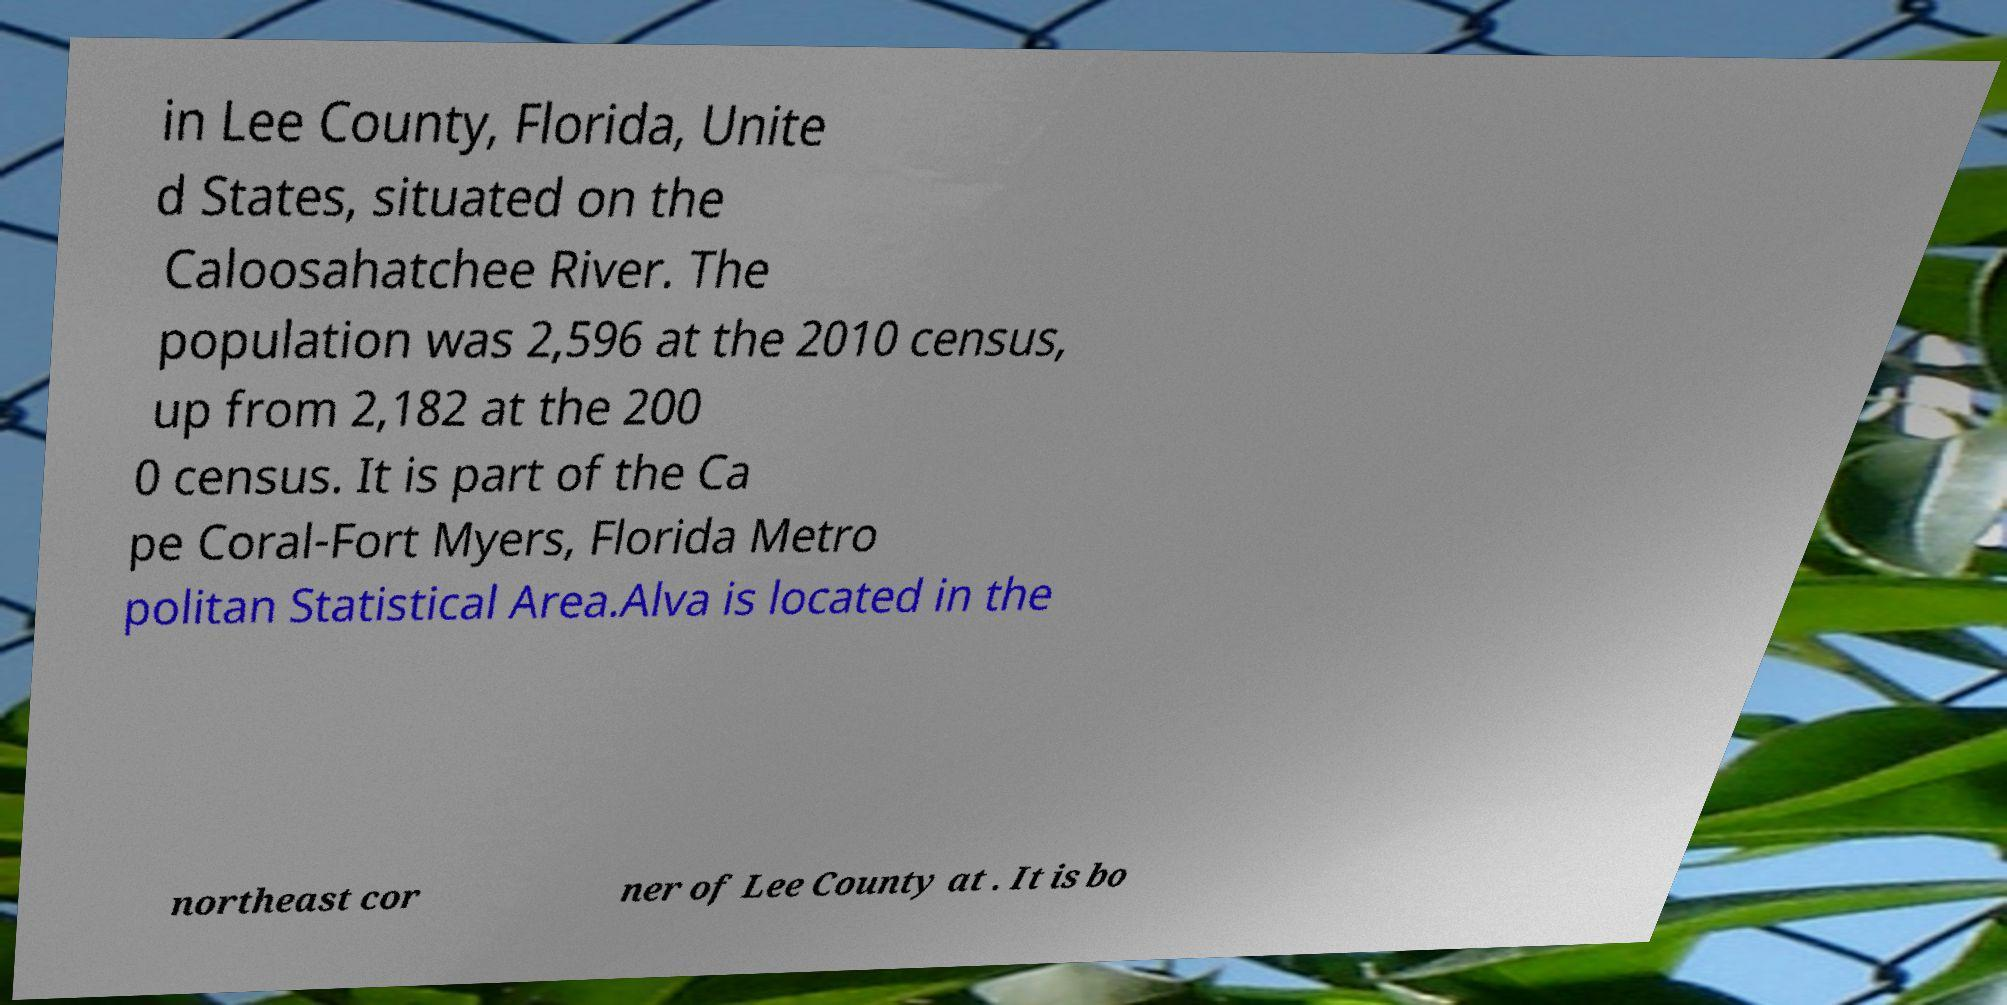Can you accurately transcribe the text from the provided image for me? in Lee County, Florida, Unite d States, situated on the Caloosahatchee River. The population was 2,596 at the 2010 census, up from 2,182 at the 200 0 census. It is part of the Ca pe Coral-Fort Myers, Florida Metro politan Statistical Area.Alva is located in the northeast cor ner of Lee County at . It is bo 